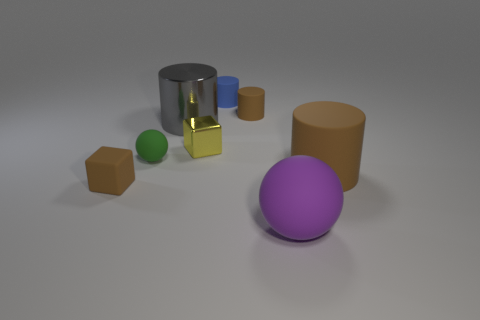How many big brown matte things have the same shape as the tiny green thing?
Offer a terse response. 0. What number of large red objects are there?
Your answer should be compact. 0. There is a cube on the left side of the small metallic object; what color is it?
Provide a succinct answer. Brown. What color is the small block that is to the right of the tiny brown rubber object that is to the left of the small green matte object?
Your answer should be compact. Yellow. There is a metal thing that is the same size as the brown rubber cube; what is its color?
Provide a succinct answer. Yellow. How many large things are both in front of the green object and behind the matte block?
Keep it short and to the point. 1. There is a big matte object that is the same color as the small rubber cube; what is its shape?
Offer a very short reply. Cylinder. There is a thing that is both in front of the tiny green sphere and left of the gray cylinder; what is its material?
Give a very brief answer. Rubber. Are there fewer gray metallic objects behind the gray metal cylinder than matte balls that are on the left side of the purple rubber object?
Offer a very short reply. Yes. What is the size of the purple ball that is made of the same material as the large brown object?
Ensure brevity in your answer.  Large. 